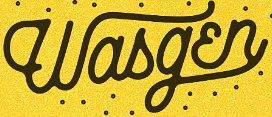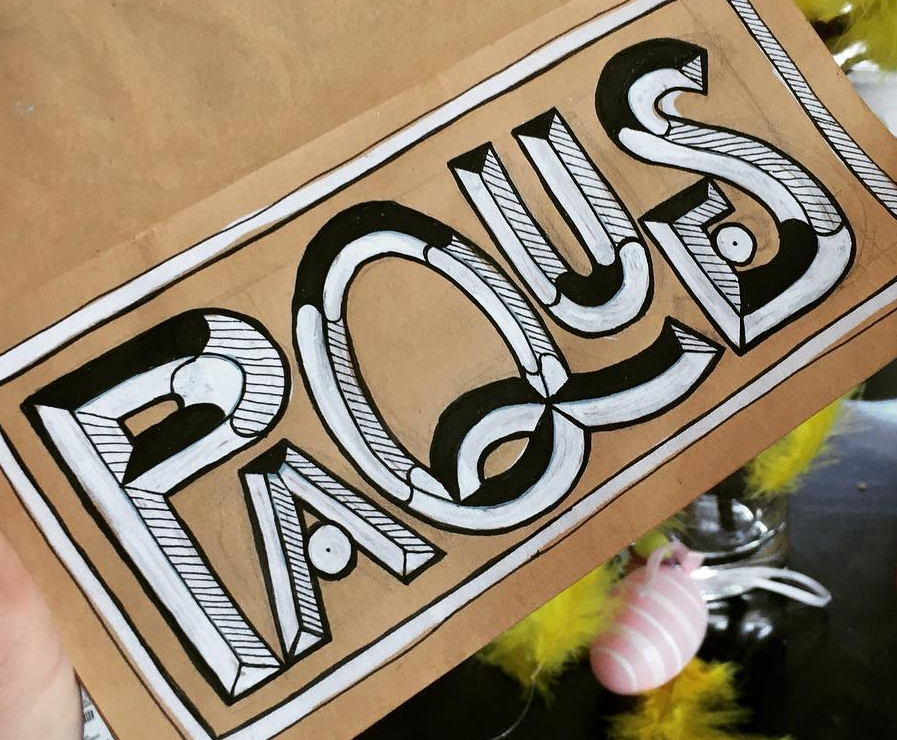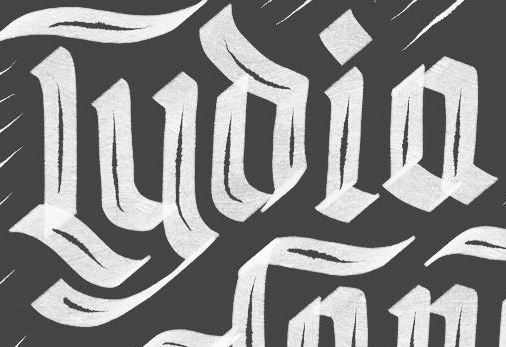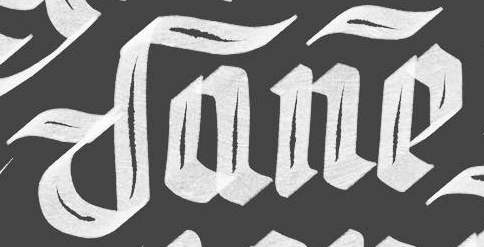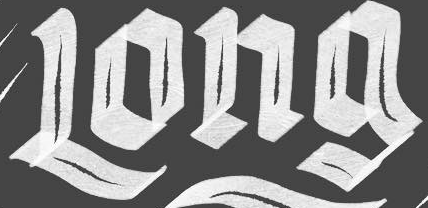What text appears in these images from left to right, separated by a semicolon? Wasgɛn; PAQUES; Lyoia; Dane; Long 